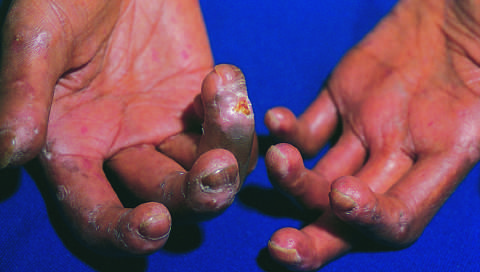has loss of blood supply led to cutaneous ulcerations?
Answer the question using a single word or phrase. Yes 